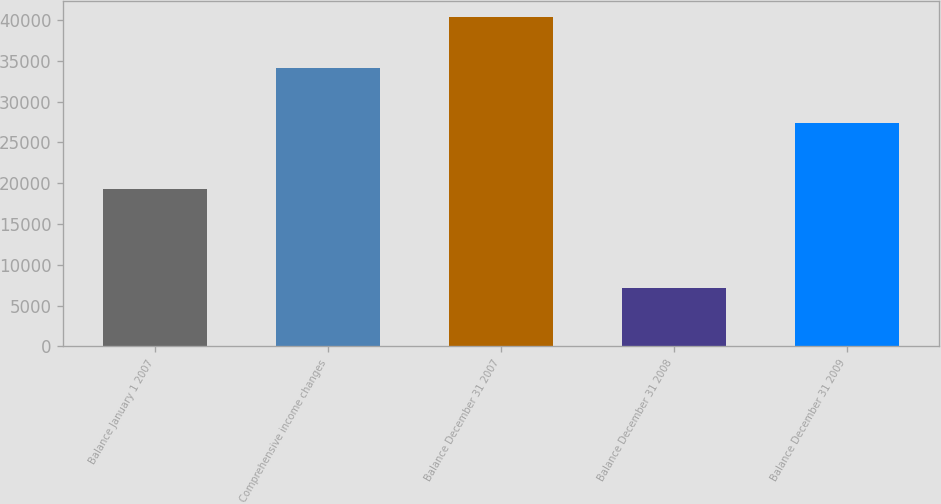Convert chart. <chart><loc_0><loc_0><loc_500><loc_500><bar_chart><fcel>Balance January 1 2007<fcel>Comprehensive income changes<fcel>Balance December 31 2007<fcel>Balance December 31 2008<fcel>Balance December 31 2009<nl><fcel>19301<fcel>34120<fcel>40335<fcel>7173<fcel>27368<nl></chart> 